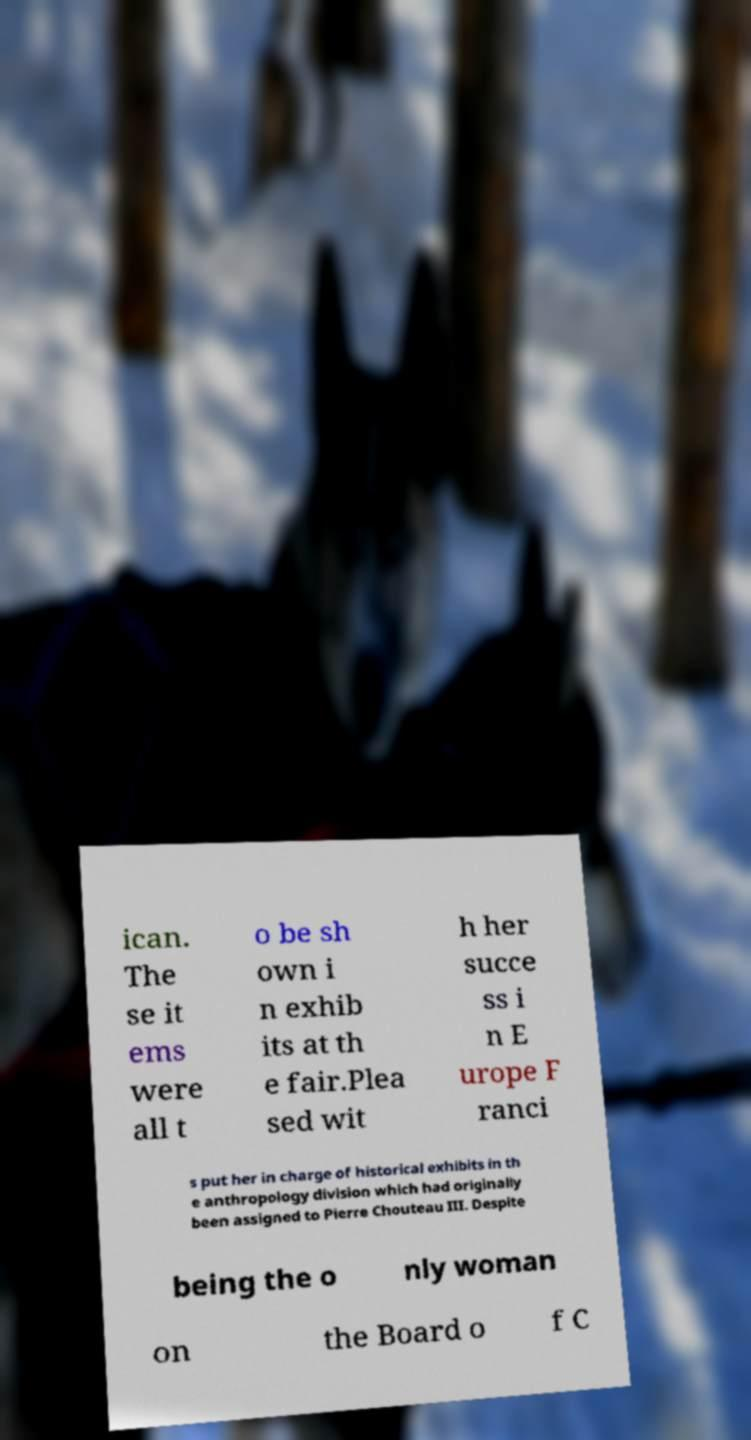For documentation purposes, I need the text within this image transcribed. Could you provide that? ican. The se it ems were all t o be sh own i n exhib its at th e fair.Plea sed wit h her succe ss i n E urope F ranci s put her in charge of historical exhibits in th e anthropology division which had originally been assigned to Pierre Chouteau III. Despite being the o nly woman on the Board o f C 